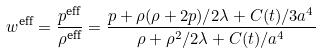<formula> <loc_0><loc_0><loc_500><loc_500>w ^ { \text {eff} } = \frac { p ^ { \text {eff} } } { \rho ^ { \text {eff} } } = \frac { p + \rho ( \rho + 2 p ) / 2 \lambda + C ( t ) / 3 a ^ { 4 } } { \rho + \rho ^ { 2 } / 2 \lambda + C ( t ) / a ^ { 4 } }</formula> 